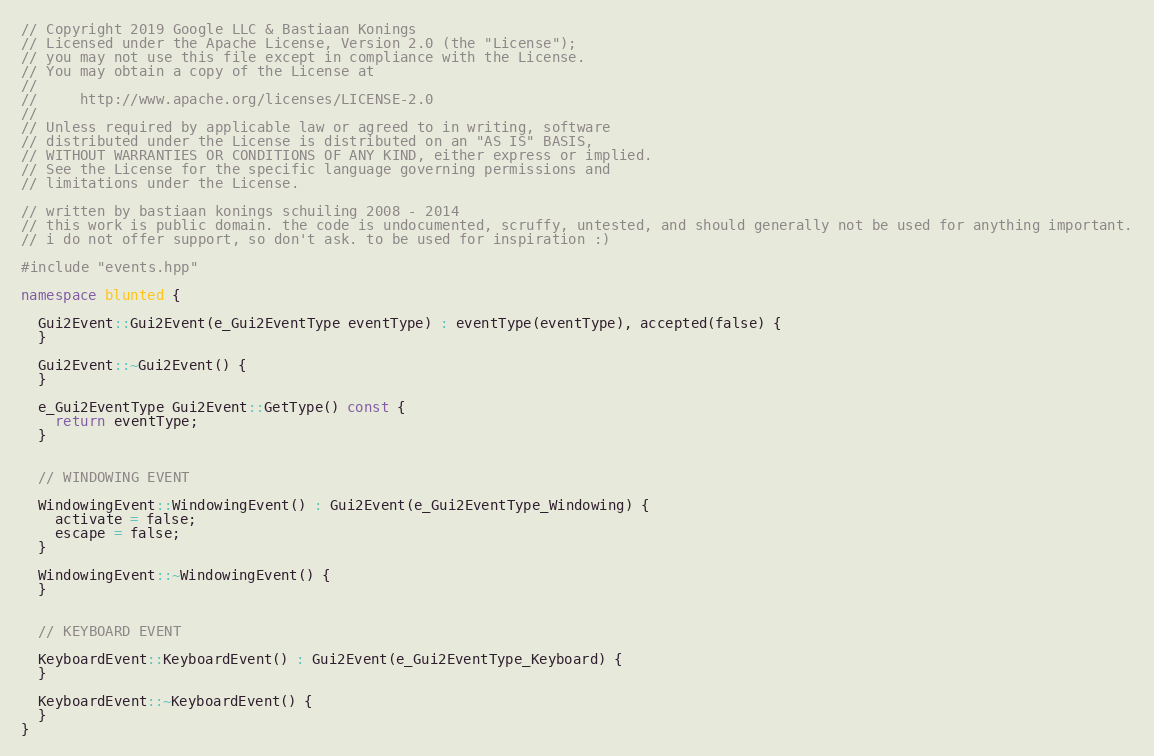<code> <loc_0><loc_0><loc_500><loc_500><_C++_>// Copyright 2019 Google LLC & Bastiaan Konings
// Licensed under the Apache License, Version 2.0 (the "License");
// you may not use this file except in compliance with the License.
// You may obtain a copy of the License at
//
//     http://www.apache.org/licenses/LICENSE-2.0
//
// Unless required by applicable law or agreed to in writing, software
// distributed under the License is distributed on an "AS IS" BASIS,
// WITHOUT WARRANTIES OR CONDITIONS OF ANY KIND, either express or implied.
// See the License for the specific language governing permissions and
// limitations under the License.

// written by bastiaan konings schuiling 2008 - 2014
// this work is public domain. the code is undocumented, scruffy, untested, and should generally not be used for anything important.
// i do not offer support, so don't ask. to be used for inspiration :)

#include "events.hpp"

namespace blunted {

  Gui2Event::Gui2Event(e_Gui2EventType eventType) : eventType(eventType), accepted(false) {
  }

  Gui2Event::~Gui2Event() {
  }

  e_Gui2EventType Gui2Event::GetType() const {
    return eventType;
  }


  // WINDOWING EVENT

  WindowingEvent::WindowingEvent() : Gui2Event(e_Gui2EventType_Windowing) {
    activate = false;
    escape = false;
  }

  WindowingEvent::~WindowingEvent() {
  }


  // KEYBOARD EVENT

  KeyboardEvent::KeyboardEvent() : Gui2Event(e_Gui2EventType_Keyboard) {
  }

  KeyboardEvent::~KeyboardEvent() {
  }
}
</code> 